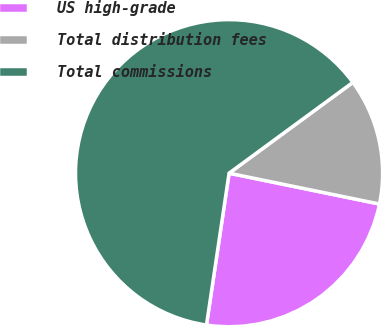<chart> <loc_0><loc_0><loc_500><loc_500><pie_chart><fcel>US high-grade<fcel>Total distribution fees<fcel>Total commissions<nl><fcel>24.13%<fcel>13.29%<fcel>62.57%<nl></chart> 